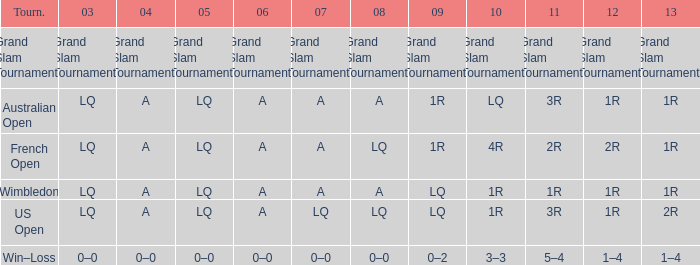Which tournament has a 2013 of 1r, and a 2012 of 1r? Australian Open, Wimbledon. 